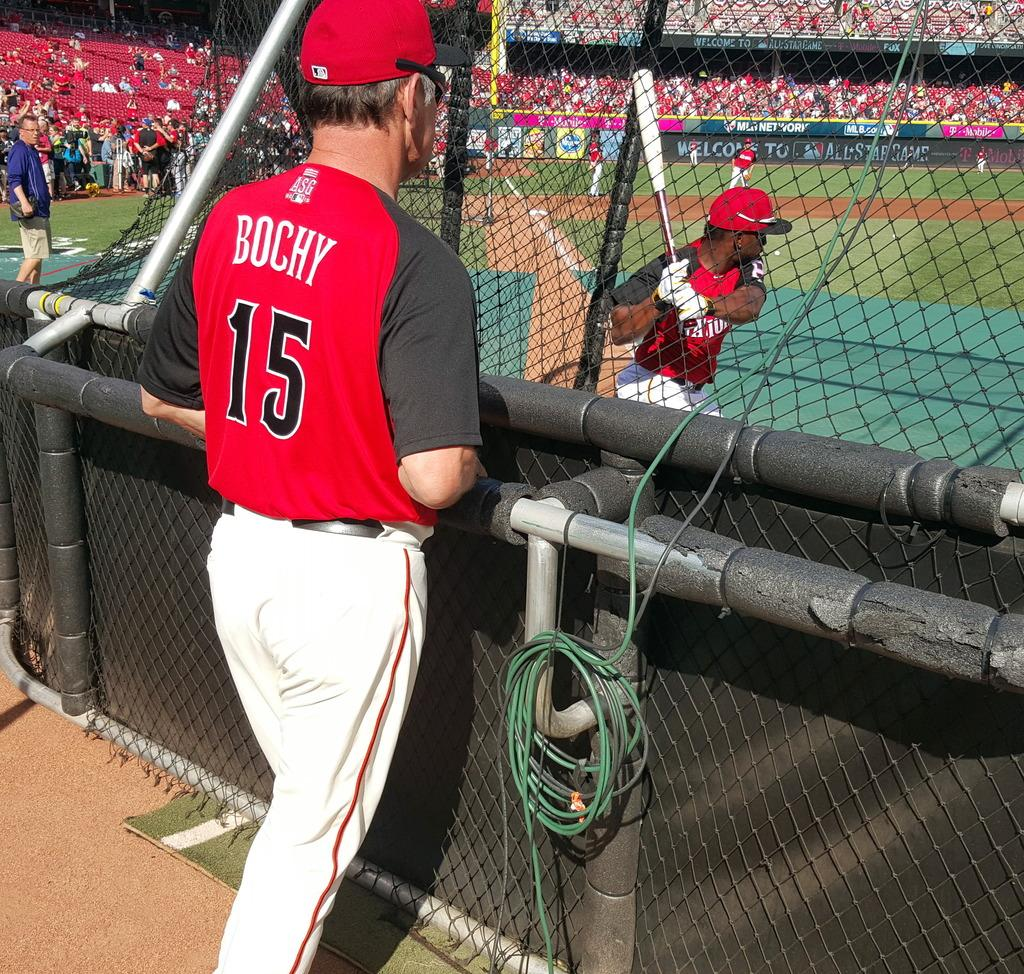<image>
Offer a succinct explanation of the picture presented. baseball coach watching his batter swing at the ball, his jersey says Bochy # 15. 